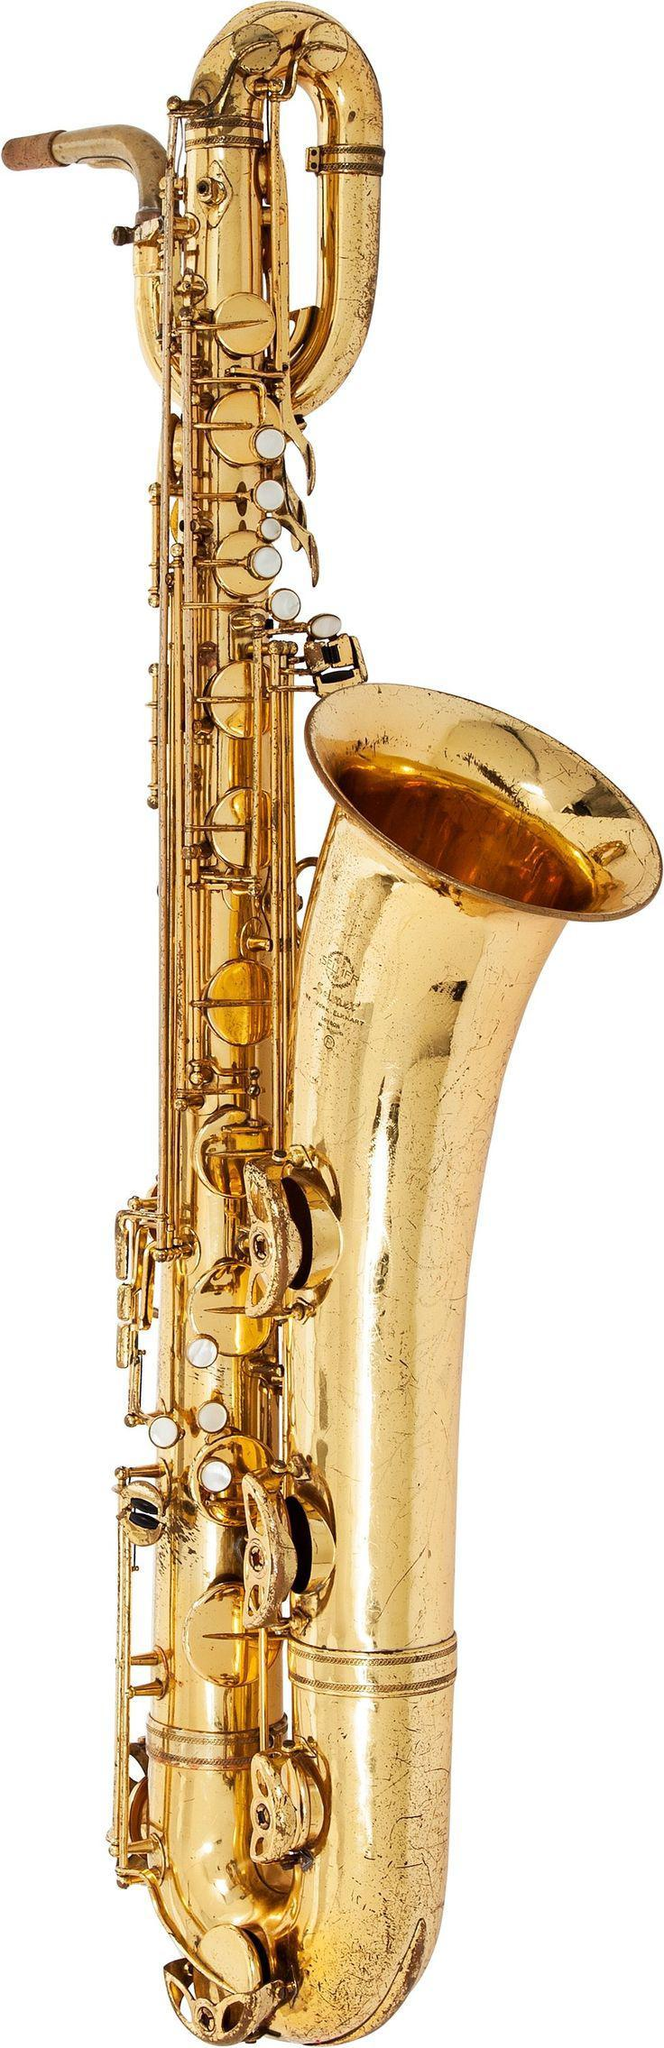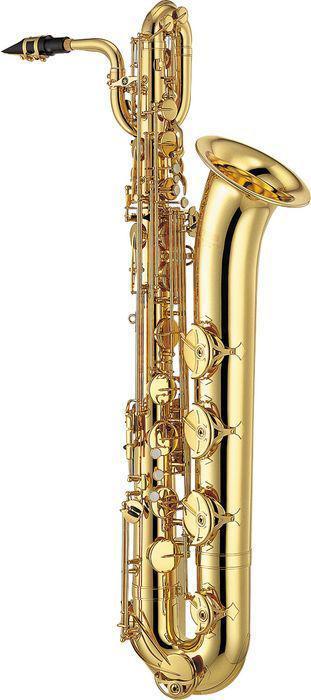The first image is the image on the left, the second image is the image on the right. Assess this claim about the two images: "There is exactly one black mouthpiece.". Correct or not? Answer yes or no. Yes. The first image is the image on the left, the second image is the image on the right. Analyze the images presented: Is the assertion "Each image shows one upright gold colored saxophone with its bell facing rightward and its mouthpiece facing leftward, and at least one of the saxophones pictured has a loop shape at the top." valid? Answer yes or no. Yes. 